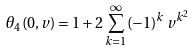Convert formula to latex. <formula><loc_0><loc_0><loc_500><loc_500>\theta _ { 4 } ( 0 , v ) = 1 + 2 \sum _ { k = 1 } ^ { \infty } ( - 1 ) ^ { k } \, v ^ { k ^ { 2 } }</formula> 